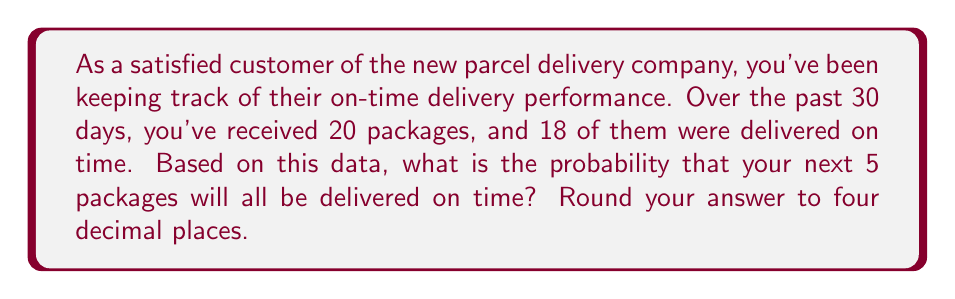Show me your answer to this math problem. To solve this problem, we'll use the concept of independent events and the multiplication rule of probability.

1. First, let's calculate the probability of a single package being delivered on time:
   $P(\text{on-time delivery}) = \frac{\text{number of on-time deliveries}}{\text{total number of deliveries}} = \frac{18}{20} = 0.9$

2. We want to find the probability of 5 consecutive on-time deliveries. Since each delivery is independent, we can use the multiplication rule of probability:

   $P(5 \text{ on-time deliveries}) = P(\text{on-time})^5$

3. Substituting our calculated probability:

   $P(5 \text{ on-time deliveries}) = (0.9)^5$

4. Calculate the result:
   $$(0.9)^5 = 0.59049$$

5. Rounding to four decimal places:
   $$0.59049 \approx 0.5905$$

Therefore, the probability that your next 5 packages will all be delivered on time is approximately 0.5905 or 59.05%.
Answer: 0.5905 